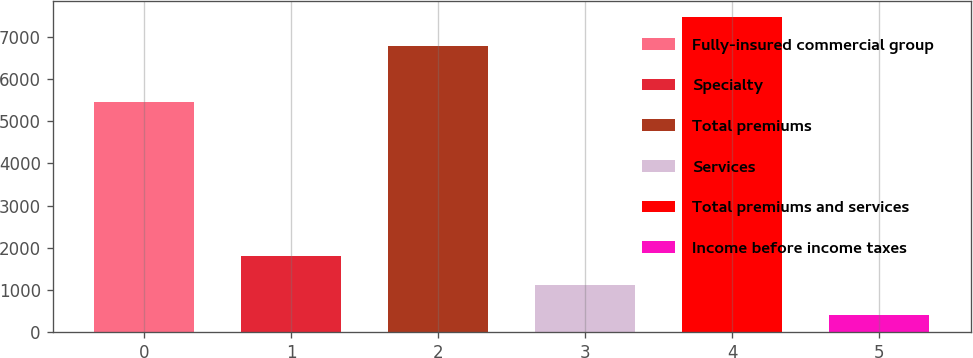Convert chart. <chart><loc_0><loc_0><loc_500><loc_500><bar_chart><fcel>Fully-insured commercial group<fcel>Specialty<fcel>Total premiums<fcel>Services<fcel>Total premiums and services<fcel>Income before income taxes<nl><fcel>5462<fcel>1809.2<fcel>6772<fcel>1110.6<fcel>7470.6<fcel>412<nl></chart> 